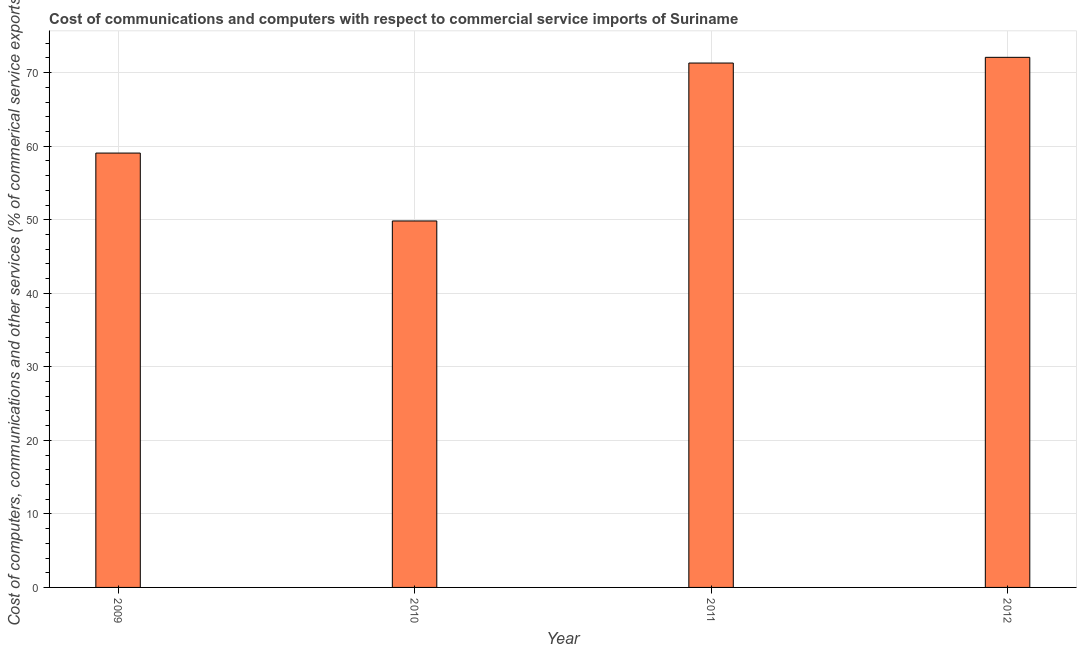What is the title of the graph?
Provide a succinct answer. Cost of communications and computers with respect to commercial service imports of Suriname. What is the label or title of the X-axis?
Your answer should be compact. Year. What is the label or title of the Y-axis?
Your answer should be compact. Cost of computers, communications and other services (% of commerical service exports). What is the cost of communications in 2012?
Make the answer very short. 72.08. Across all years, what is the maximum cost of communications?
Provide a short and direct response. 72.08. Across all years, what is the minimum  computer and other services?
Offer a terse response. 49.83. What is the sum of the  computer and other services?
Make the answer very short. 252.28. What is the difference between the cost of communications in 2011 and 2012?
Provide a short and direct response. -0.78. What is the average  computer and other services per year?
Make the answer very short. 63.07. What is the median cost of communications?
Offer a terse response. 65.19. In how many years, is the cost of communications greater than 36 %?
Offer a very short reply. 4. Do a majority of the years between 2011 and 2010 (inclusive) have cost of communications greater than 52 %?
Your answer should be compact. No. What is the ratio of the  computer and other services in 2010 to that in 2012?
Your answer should be very brief. 0.69. What is the difference between the highest and the second highest cost of communications?
Offer a terse response. 0.78. What is the difference between the highest and the lowest  computer and other services?
Make the answer very short. 22.25. In how many years, is the  computer and other services greater than the average  computer and other services taken over all years?
Your answer should be compact. 2. Are all the bars in the graph horizontal?
Make the answer very short. No. How many years are there in the graph?
Your response must be concise. 4. What is the difference between two consecutive major ticks on the Y-axis?
Provide a succinct answer. 10. What is the Cost of computers, communications and other services (% of commerical service exports) in 2009?
Provide a short and direct response. 59.06. What is the Cost of computers, communications and other services (% of commerical service exports) of 2010?
Provide a succinct answer. 49.83. What is the Cost of computers, communications and other services (% of commerical service exports) of 2011?
Your answer should be compact. 71.31. What is the Cost of computers, communications and other services (% of commerical service exports) in 2012?
Keep it short and to the point. 72.08. What is the difference between the Cost of computers, communications and other services (% of commerical service exports) in 2009 and 2010?
Make the answer very short. 9.23. What is the difference between the Cost of computers, communications and other services (% of commerical service exports) in 2009 and 2011?
Give a very brief answer. -12.24. What is the difference between the Cost of computers, communications and other services (% of commerical service exports) in 2009 and 2012?
Keep it short and to the point. -13.02. What is the difference between the Cost of computers, communications and other services (% of commerical service exports) in 2010 and 2011?
Your answer should be compact. -21.48. What is the difference between the Cost of computers, communications and other services (% of commerical service exports) in 2010 and 2012?
Provide a succinct answer. -22.25. What is the difference between the Cost of computers, communications and other services (% of commerical service exports) in 2011 and 2012?
Ensure brevity in your answer.  -0.78. What is the ratio of the Cost of computers, communications and other services (% of commerical service exports) in 2009 to that in 2010?
Your response must be concise. 1.19. What is the ratio of the Cost of computers, communications and other services (% of commerical service exports) in 2009 to that in 2011?
Provide a succinct answer. 0.83. What is the ratio of the Cost of computers, communications and other services (% of commerical service exports) in 2009 to that in 2012?
Make the answer very short. 0.82. What is the ratio of the Cost of computers, communications and other services (% of commerical service exports) in 2010 to that in 2011?
Your answer should be very brief. 0.7. What is the ratio of the Cost of computers, communications and other services (% of commerical service exports) in 2010 to that in 2012?
Your answer should be very brief. 0.69. 